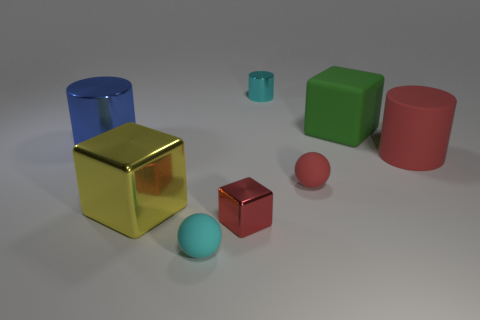Is the number of blue cylinders greater than the number of big red cubes?
Offer a very short reply. Yes. How big is the matte sphere in front of the shiny cube that is on the left side of the small metal thing that is in front of the big green cube?
Provide a succinct answer. Small. There is a green thing; does it have the same size as the red thing right of the matte cube?
Your answer should be very brief. Yes. Is the number of small cylinders that are behind the small cyan metal cylinder less than the number of small red cubes?
Keep it short and to the point. Yes. What number of rubber cylinders have the same color as the tiny block?
Offer a very short reply. 1. Are there fewer cyan rubber things than tiny balls?
Offer a terse response. Yes. Does the big green block have the same material as the red ball?
Your answer should be compact. Yes. There is a tiny matte object that is to the right of the tiny thing to the left of the small metallic cube; what is its color?
Your answer should be very brief. Red. What number of other things are there of the same shape as the big red matte object?
Make the answer very short. 2. Are there any other balls made of the same material as the small cyan ball?
Provide a short and direct response. Yes. 